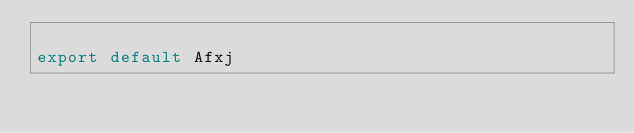<code> <loc_0><loc_0><loc_500><loc_500><_TypeScript_>
export default Afxj
</code> 